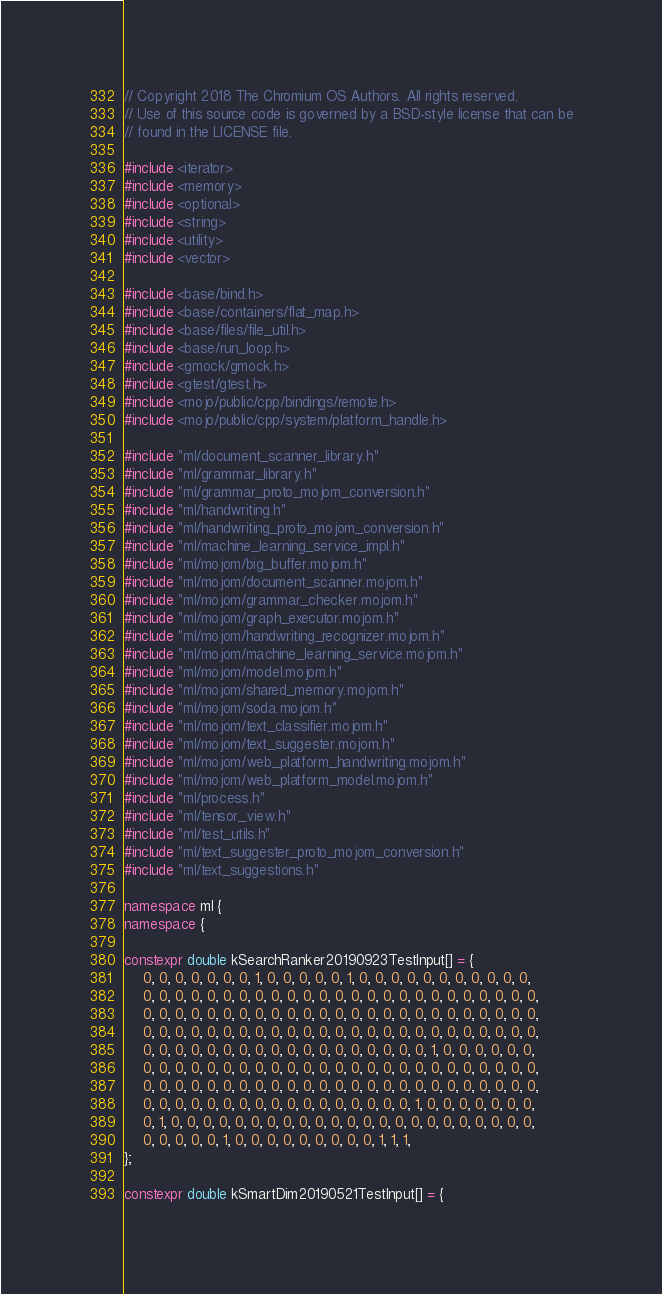Convert code to text. <code><loc_0><loc_0><loc_500><loc_500><_C++_>// Copyright 2018 The Chromium OS Authors. All rights reserved.
// Use of this source code is governed by a BSD-style license that can be
// found in the LICENSE file.

#include <iterator>
#include <memory>
#include <optional>
#include <string>
#include <utility>
#include <vector>

#include <base/bind.h>
#include <base/containers/flat_map.h>
#include <base/files/file_util.h>
#include <base/run_loop.h>
#include <gmock/gmock.h>
#include <gtest/gtest.h>
#include <mojo/public/cpp/bindings/remote.h>
#include <mojo/public/cpp/system/platform_handle.h>

#include "ml/document_scanner_library.h"
#include "ml/grammar_library.h"
#include "ml/grammar_proto_mojom_conversion.h"
#include "ml/handwriting.h"
#include "ml/handwriting_proto_mojom_conversion.h"
#include "ml/machine_learning_service_impl.h"
#include "ml/mojom/big_buffer.mojom.h"
#include "ml/mojom/document_scanner.mojom.h"
#include "ml/mojom/grammar_checker.mojom.h"
#include "ml/mojom/graph_executor.mojom.h"
#include "ml/mojom/handwriting_recognizer.mojom.h"
#include "ml/mojom/machine_learning_service.mojom.h"
#include "ml/mojom/model.mojom.h"
#include "ml/mojom/shared_memory.mojom.h"
#include "ml/mojom/soda.mojom.h"
#include "ml/mojom/text_classifier.mojom.h"
#include "ml/mojom/text_suggester.mojom.h"
#include "ml/mojom/web_platform_handwriting.mojom.h"
#include "ml/mojom/web_platform_model.mojom.h"
#include "ml/process.h"
#include "ml/tensor_view.h"
#include "ml/test_utils.h"
#include "ml/text_suggester_proto_mojom_conversion.h"
#include "ml/text_suggestions.h"

namespace ml {
namespace {

constexpr double kSearchRanker20190923TestInput[] = {
    0, 0, 0, 0, 0, 0, 0, 1, 0, 0, 0, 0, 0, 1, 0, 0, 0, 0, 0, 0, 0, 0, 0, 0, 0,
    0, 0, 0, 0, 0, 0, 0, 0, 0, 0, 0, 0, 0, 0, 0, 0, 0, 0, 0, 0, 0, 0, 0, 0, 0,
    0, 0, 0, 0, 0, 0, 0, 0, 0, 0, 0, 0, 0, 0, 0, 0, 0, 0, 0, 0, 0, 0, 0, 0, 0,
    0, 0, 0, 0, 0, 0, 0, 0, 0, 0, 0, 0, 0, 0, 0, 0, 0, 0, 0, 0, 0, 0, 0, 0, 0,
    0, 0, 0, 0, 0, 0, 0, 0, 0, 0, 0, 0, 0, 0, 0, 0, 0, 0, 1, 0, 0, 0, 0, 0, 0,
    0, 0, 0, 0, 0, 0, 0, 0, 0, 0, 0, 0, 0, 0, 0, 0, 0, 0, 0, 0, 0, 0, 0, 0, 0,
    0, 0, 0, 0, 0, 0, 0, 0, 0, 0, 0, 0, 0, 0, 0, 0, 0, 0, 0, 0, 0, 0, 0, 0, 0,
    0, 0, 0, 0, 0, 0, 0, 0, 0, 0, 0, 0, 0, 0, 0, 0, 0, 1, 0, 0, 0, 0, 0, 0, 0,
    0, 1, 0, 0, 0, 0, 0, 0, 0, 0, 0, 0, 0, 0, 0, 0, 0, 0, 0, 0, 0, 0, 0, 0, 0,
    0, 0, 0, 0, 0, 1, 0, 0, 0, 0, 0, 0, 0, 0, 0, 1, 1, 1,
};

constexpr double kSmartDim20190521TestInput[] = {</code> 